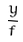Convert formula to latex. <formula><loc_0><loc_0><loc_500><loc_500>\frac { y } { f }</formula> 